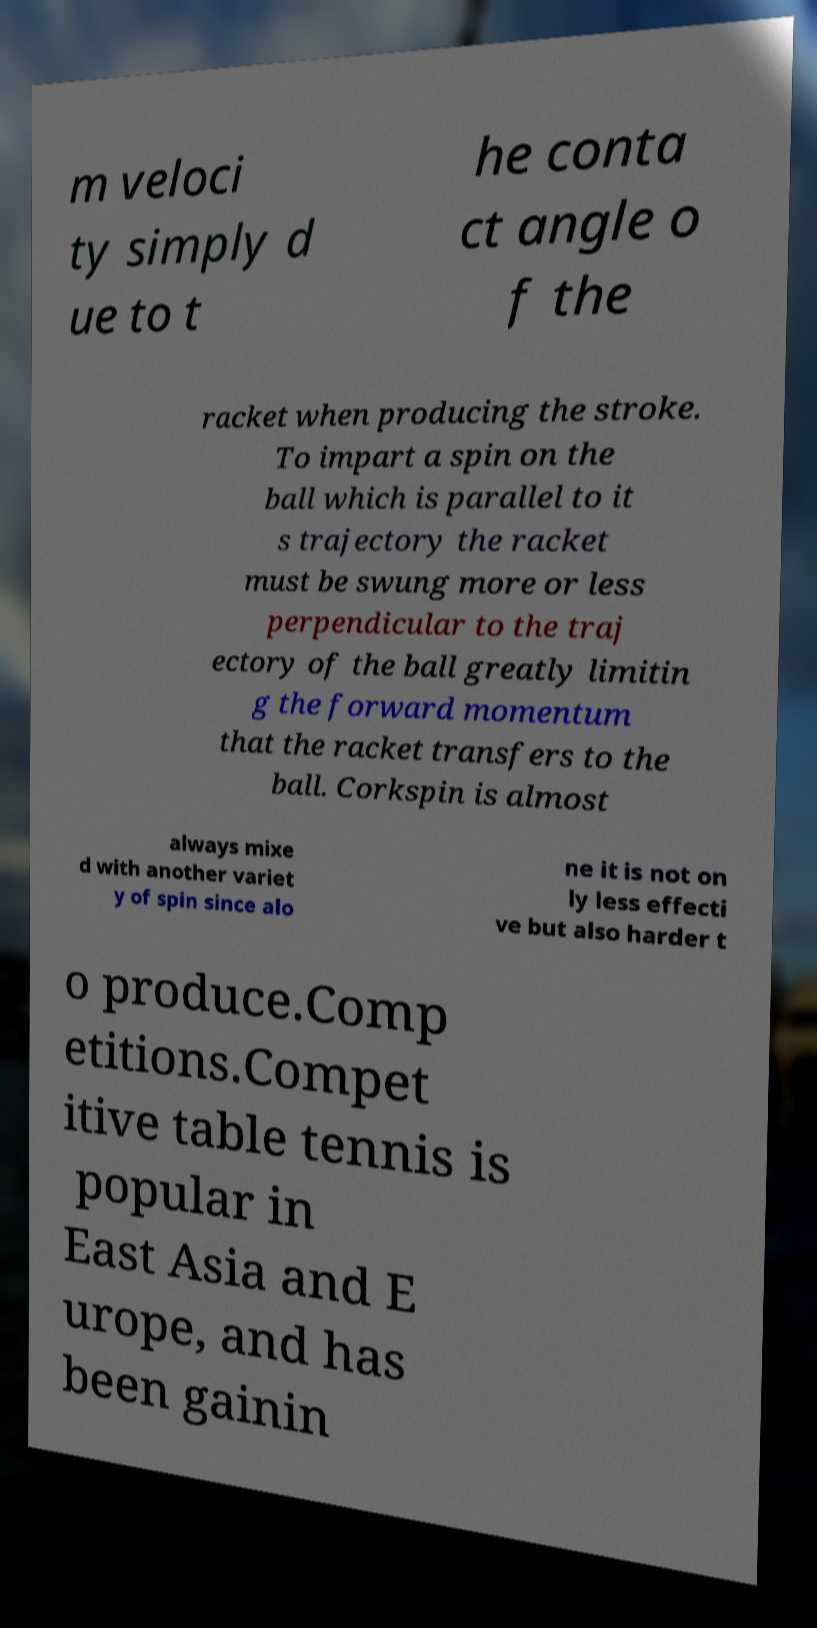For documentation purposes, I need the text within this image transcribed. Could you provide that? m veloci ty simply d ue to t he conta ct angle o f the racket when producing the stroke. To impart a spin on the ball which is parallel to it s trajectory the racket must be swung more or less perpendicular to the traj ectory of the ball greatly limitin g the forward momentum that the racket transfers to the ball. Corkspin is almost always mixe d with another variet y of spin since alo ne it is not on ly less effecti ve but also harder t o produce.Comp etitions.Compet itive table tennis is popular in East Asia and E urope, and has been gainin 